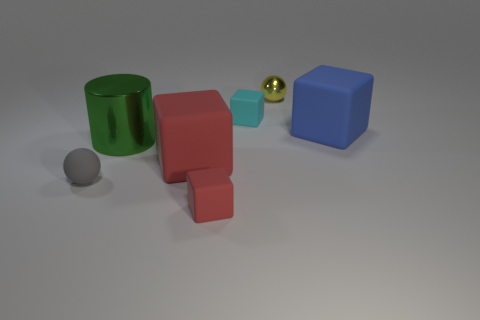There is a matte object to the left of the big green metallic object; does it have the same shape as the shiny thing that is to the right of the large green object?
Offer a terse response. Yes. Is there a red thing of the same size as the green thing?
Your answer should be very brief. Yes. How many purple objects are rubber cubes or big metallic cylinders?
Make the answer very short. 0. Are there any other things that are the same shape as the large metallic thing?
Your answer should be very brief. No. What number of cubes are brown objects or small yellow metal objects?
Your answer should be compact. 0. There is a big matte object on the left side of the small yellow thing; what color is it?
Offer a very short reply. Red. What is the shape of the blue matte object that is the same size as the green cylinder?
Your answer should be compact. Cube. There is a small yellow metallic ball; what number of matte things are on the right side of it?
Keep it short and to the point. 1. How many objects are either tiny red rubber blocks or green metallic things?
Your response must be concise. 2. There is a matte thing that is both behind the large red rubber thing and left of the blue thing; what is its shape?
Your answer should be compact. Cube. 